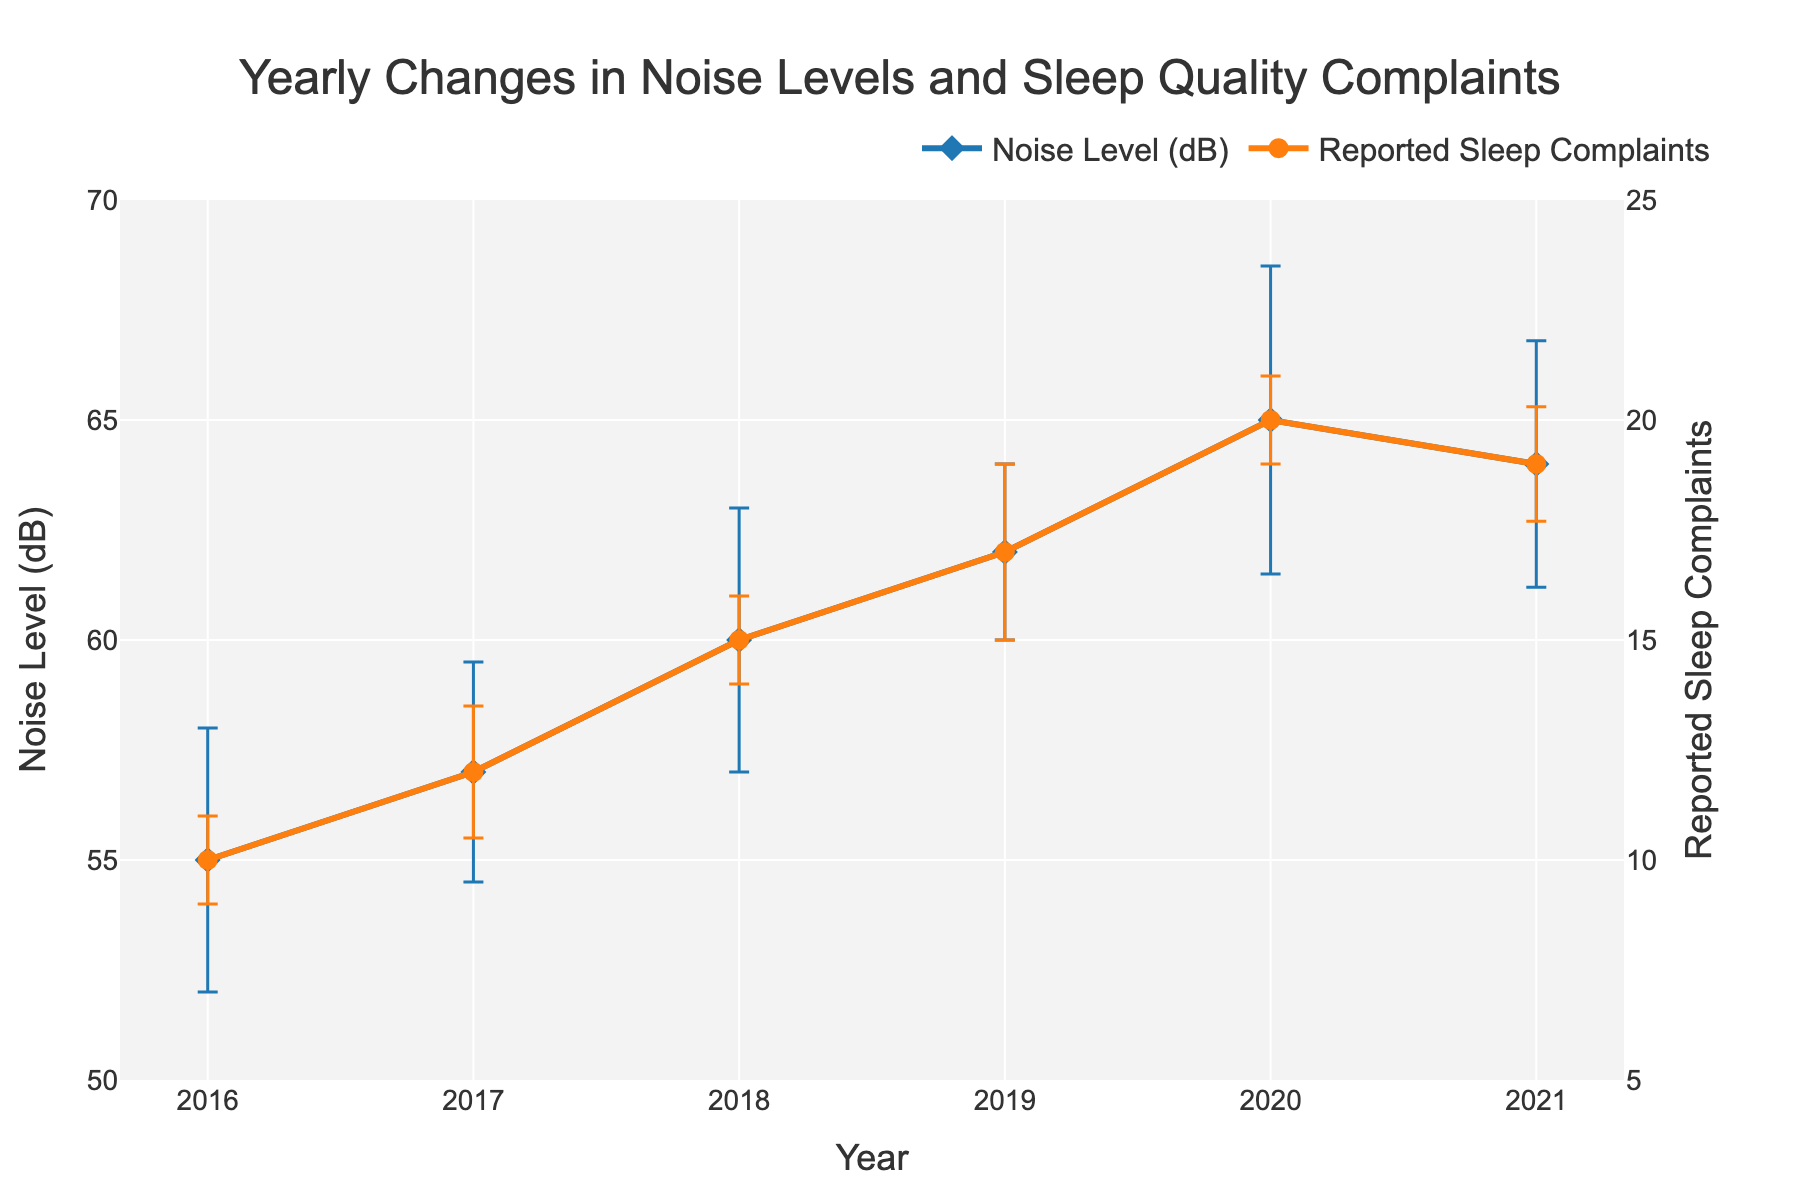what is the title of the plot? The title of the plot is positioned at the top center and summarizes what the graph is about.
Answer: Yearly Changes in Noise Levels and Sleep Quality Complaints How has the noise level changed from 2016 to 2021? The noise level increased from 55 dB in 2016 to 64 dB in 2021. By inspecting the blue line, one can see that it generally trends upwards despite minor fluctuations.
Answer: Increased What was the highest reported sleep complaint among seniors? Look for the peak on the orange line. The highest reported sleep complaint value is when the y-axis value of the orange line is at its maximum.
Answer: 20 In which year did the reported sleep complaints decrease compared to the previous year? By comparing consecutive data points on the orange line, we find that the value decreases between 2020 and 2021 (from 20 to 19).
Answer: 2021 Which year showed more variability in noise levels as indicated by the error bars? Variability is indicated by the length of the error bars. The longest blue error bar, representing the highest variability, appears around 2020.
Answer: 2020 What was the difference between noise levels in 2020 and 2021? The noise level in 2020 was 65 dB and in 2021 it was 64 dB. Subtract the value of 2021 from 2020: 65 - 64 = 1.
Answer: 1 dB Were the reported sleep complaints positively correlated with noise levels? Both the blue and orange lines generally trend upwards together over the years, indicating that as noise levels increased, so did the sleep complaints.
Answer: Yes What is the average noise level from 2016 to 2021? Sum the noise levels from each year (55 + 57 + 60 + 62 + 65 + 64) and divide by the number of years (6). The calculation is (55 + 57 + 60 + 62 + 65 + 64) / 6 = 60.5.
Answer: 60.5 dB What is the largest error margin seen in the noise levels? Review the error bar values for each year. The year 2020 has the largest error margin at 3.5 dB.
Answer: 3.5 dB What were the noise levels in the years where sleep complaints were either highest or lowest? The highest sleep complaints were in 2020 (20 complaints) and the lowest were in 2016 (10 complaints). The corresponding noise levels are 65 dB in 2020 and 55 dB in 2016.
Answer: 65 dB in 2020 and 55 dB in 2016 